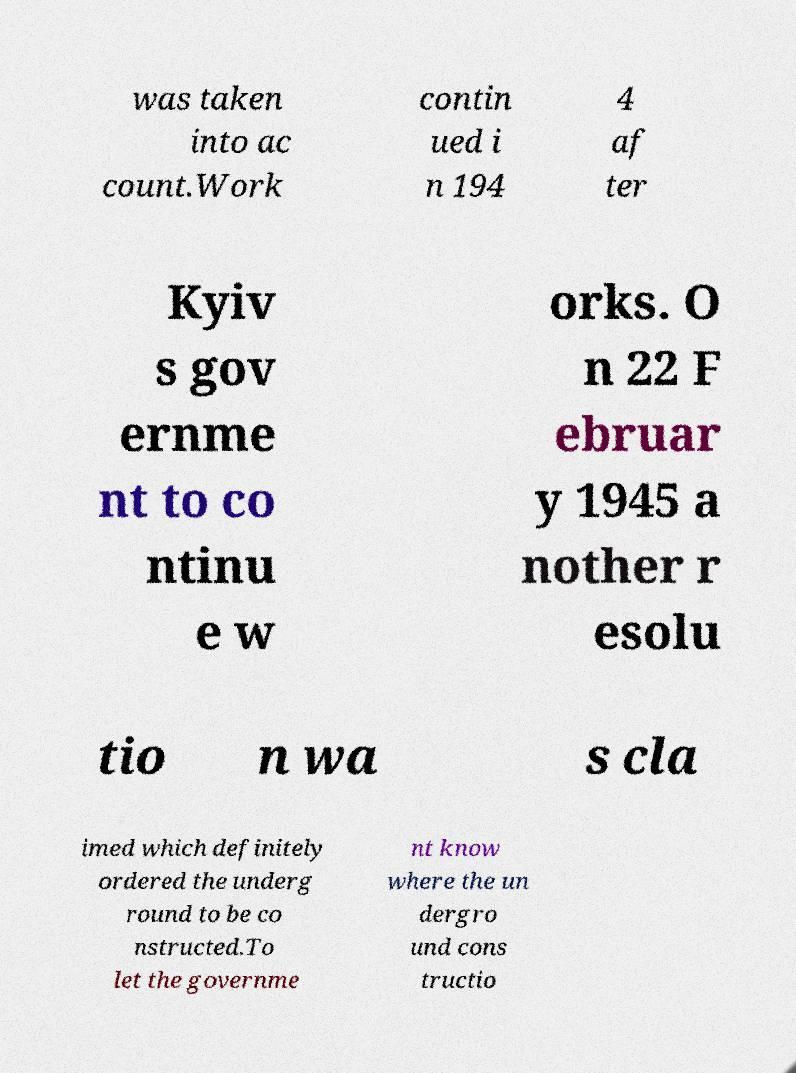Can you read and provide the text displayed in the image?This photo seems to have some interesting text. Can you extract and type it out for me? was taken into ac count.Work contin ued i n 194 4 af ter Kyiv s gov ernme nt to co ntinu e w orks. O n 22 F ebruar y 1945 a nother r esolu tio n wa s cla imed which definitely ordered the underg round to be co nstructed.To let the governme nt know where the un dergro und cons tructio 